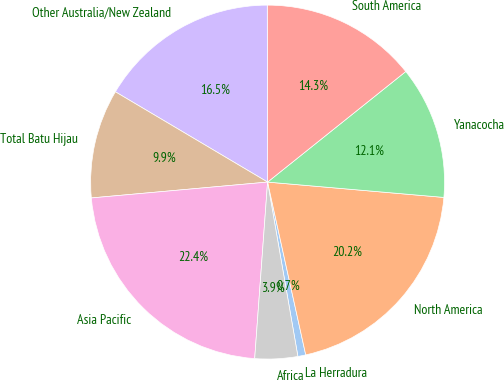Convert chart to OTSL. <chart><loc_0><loc_0><loc_500><loc_500><pie_chart><fcel>La Herradura<fcel>North America<fcel>Yanacocha<fcel>South America<fcel>Other Australia/New Zealand<fcel>Total Batu Hijau<fcel>Asia Pacific<fcel>Africa<nl><fcel>0.72%<fcel>20.16%<fcel>12.12%<fcel>14.29%<fcel>16.45%<fcel>9.95%<fcel>22.41%<fcel>3.9%<nl></chart> 